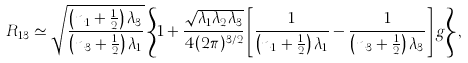Convert formula to latex. <formula><loc_0><loc_0><loc_500><loc_500>R _ { 1 3 } \simeq \sqrt { \frac { \left ( n _ { 1 } + \frac { 1 } { 2 } \right ) \lambda _ { 3 } } { \left ( n _ { 3 } + \frac { 1 } { 2 } \right ) \lambda _ { 1 } } } \left \{ 1 + \frac { \sqrt { \lambda _ { 1 } \lambda _ { 2 } \lambda _ { 3 } } } { 4 ( 2 \pi ) ^ { 3 / 2 } } \left [ \frac { 1 } { \left ( n _ { 1 } + \frac { 1 } { 2 } \right ) \lambda _ { 1 } } - \frac { 1 } { \left ( n _ { 3 } + \frac { 1 } { 2 } \right ) \lambda _ { 3 } } \right ] g \right \} ,</formula> 